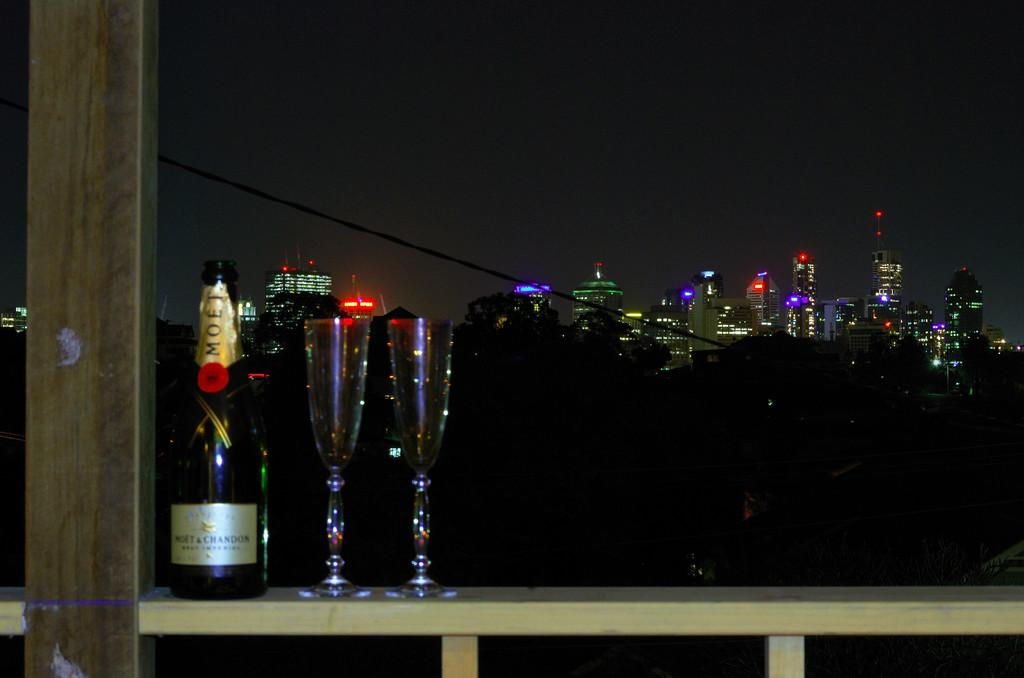<image>
Render a clear and concise summary of the photo. bottle of moet & chandon next to 2 glasses on a railing with a nighttime city in the background 